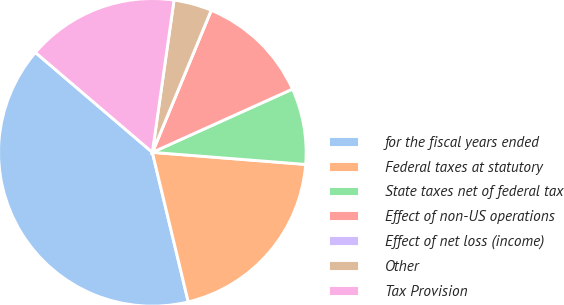Convert chart. <chart><loc_0><loc_0><loc_500><loc_500><pie_chart><fcel>for the fiscal years ended<fcel>Federal taxes at statutory<fcel>State taxes net of federal tax<fcel>Effect of non-US operations<fcel>Effect of net loss (income)<fcel>Other<fcel>Tax Provision<nl><fcel>40.0%<fcel>20.0%<fcel>8.0%<fcel>12.0%<fcel>0.0%<fcel>4.0%<fcel>16.0%<nl></chart> 